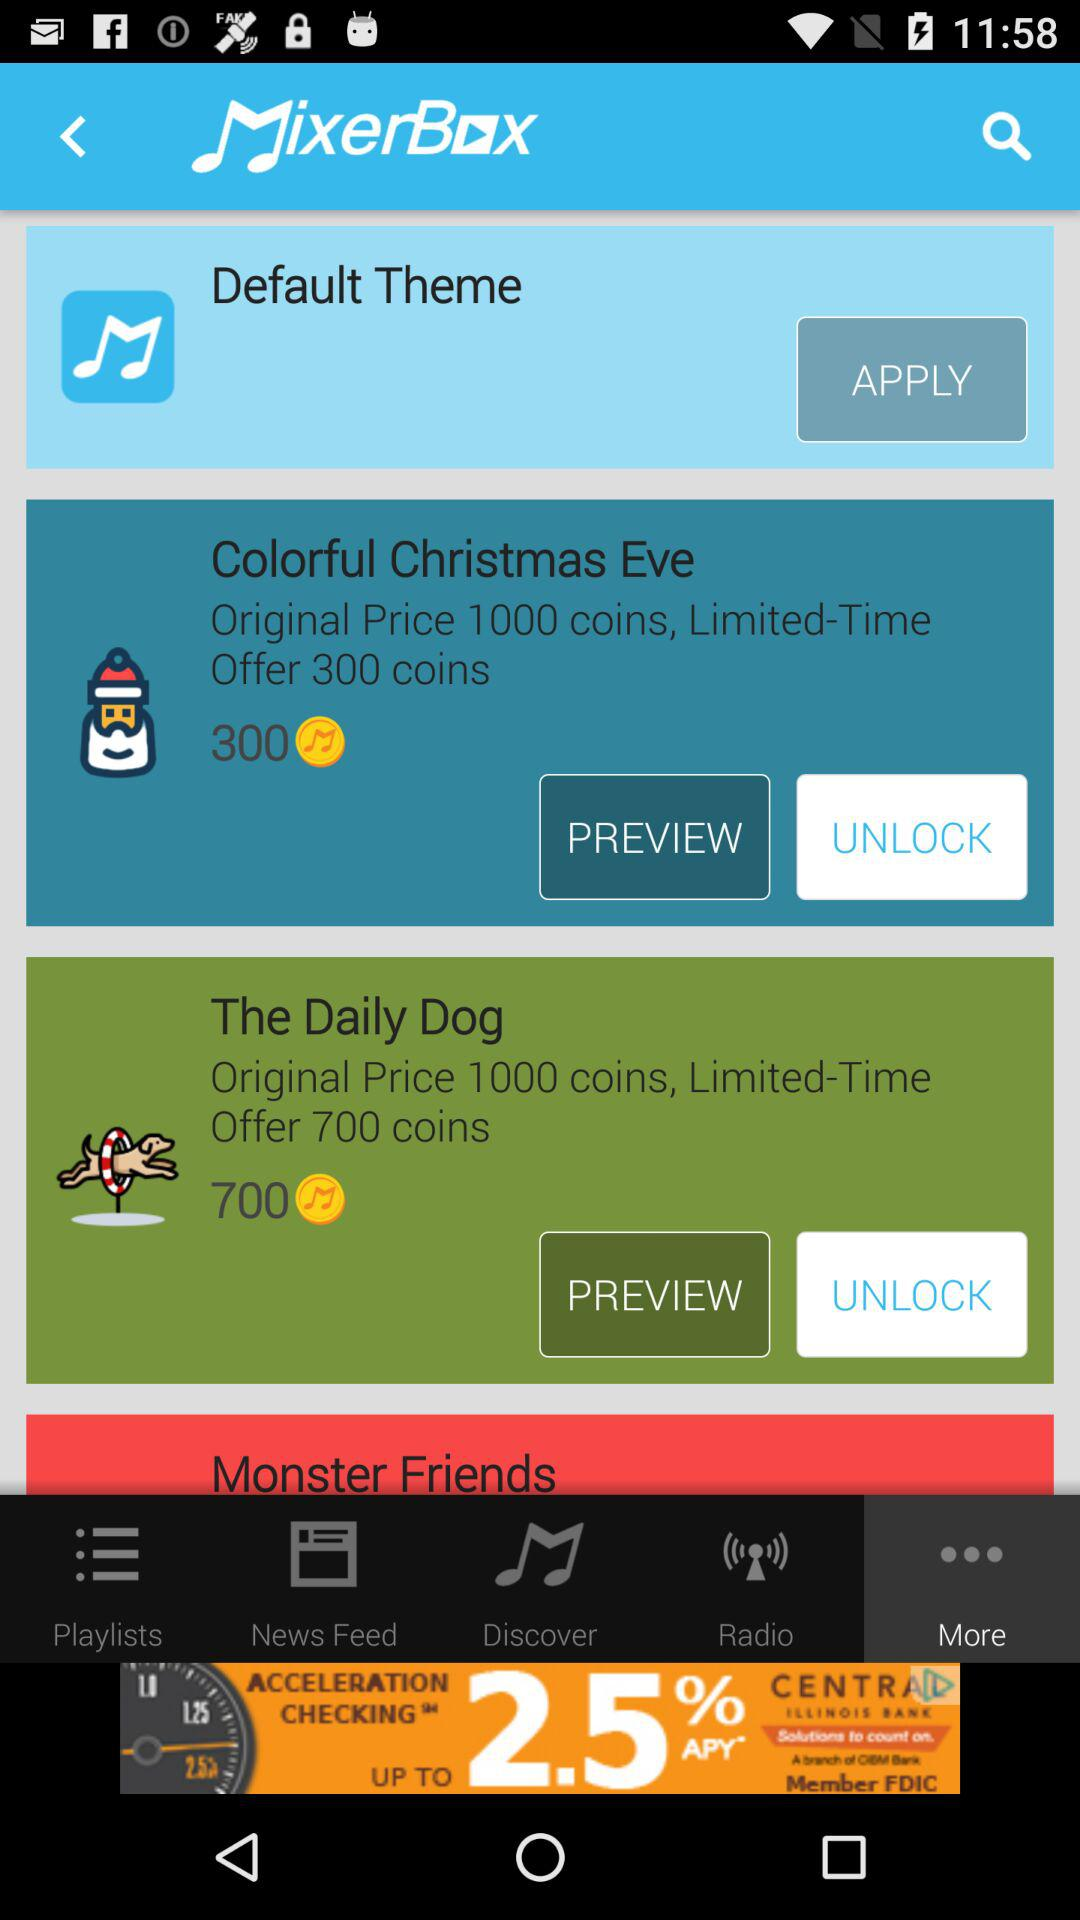How many more coins are required to unlock The Daily Dog than Colorful Christmas Eve?
Answer the question using a single word or phrase. 400 